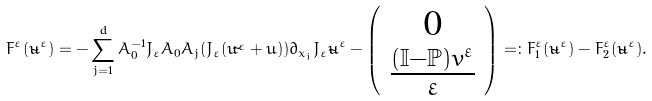Convert formula to latex. <formula><loc_0><loc_0><loc_500><loc_500>F ^ { \varepsilon } ( \tilde { u } ^ { \varepsilon } ) = - \sum _ { j = 1 } ^ { d } A _ { 0 } ^ { - 1 } J _ { \varepsilon } A _ { 0 } A _ { j } ( J _ { \varepsilon } ( \tilde { u ^ { \varepsilon } } + \bar { u } ) ) \partial _ { x _ { j } } J _ { \varepsilon } \tilde { u } ^ { \varepsilon } - \left ( \begin{array} { c } 0 \\ \frac { ( \mathbb { I } - \mathbb { P } ) v ^ { \varepsilon } } { \varepsilon } \\ \end{array} \right ) = \colon F _ { 1 } ^ { \varepsilon } ( \tilde { u } ^ { \varepsilon } ) - F _ { 2 } ^ { \varepsilon } ( \tilde { u } ^ { \varepsilon } ) .</formula> 